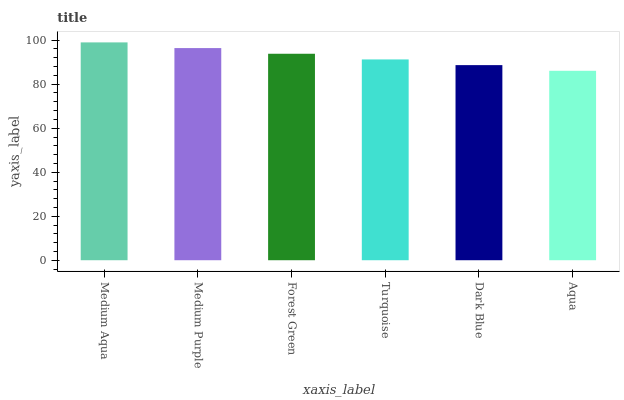Is Aqua the minimum?
Answer yes or no. Yes. Is Medium Aqua the maximum?
Answer yes or no. Yes. Is Medium Purple the minimum?
Answer yes or no. No. Is Medium Purple the maximum?
Answer yes or no. No. Is Medium Aqua greater than Medium Purple?
Answer yes or no. Yes. Is Medium Purple less than Medium Aqua?
Answer yes or no. Yes. Is Medium Purple greater than Medium Aqua?
Answer yes or no. No. Is Medium Aqua less than Medium Purple?
Answer yes or no. No. Is Forest Green the high median?
Answer yes or no. Yes. Is Turquoise the low median?
Answer yes or no. Yes. Is Medium Purple the high median?
Answer yes or no. No. Is Dark Blue the low median?
Answer yes or no. No. 